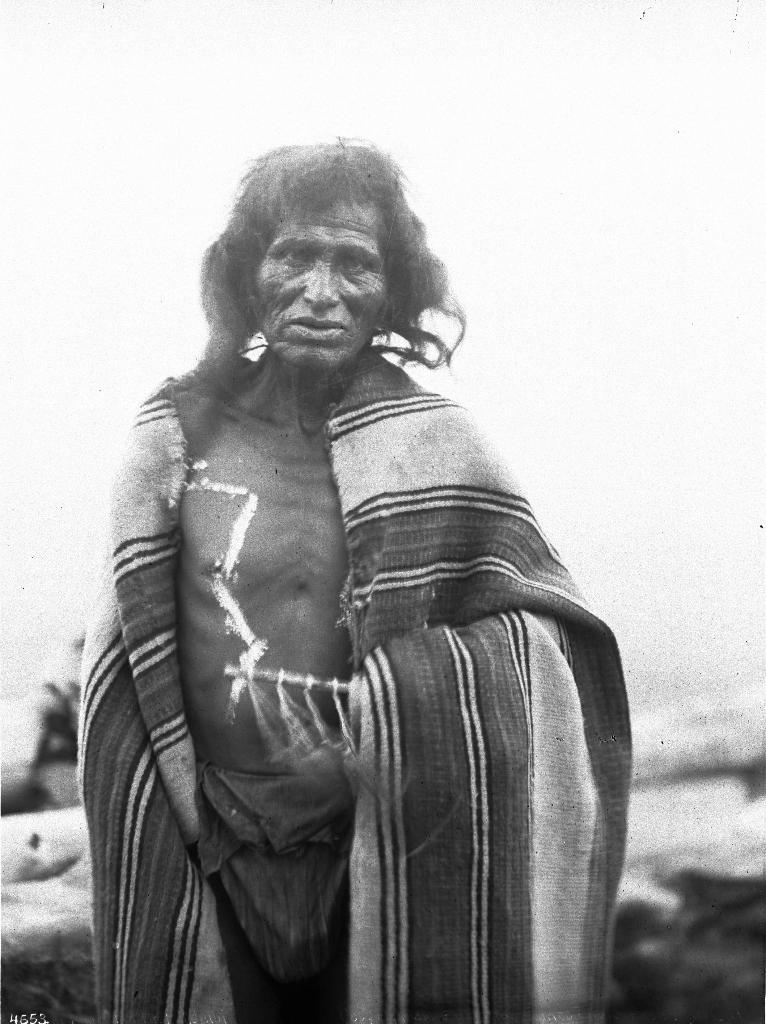What is the color scheme of the image? The image is black and white. Who is the main subject in the image? There is an old man in the image. How is the old man dressed or covered? The old man is covered with a shawl. What is the old man doing in the image? The old man is standing and looking at someone. What type of apparatus is the old man using to communicate with the goldfish in the image? There is no apparatus or goldfish present in the image. 